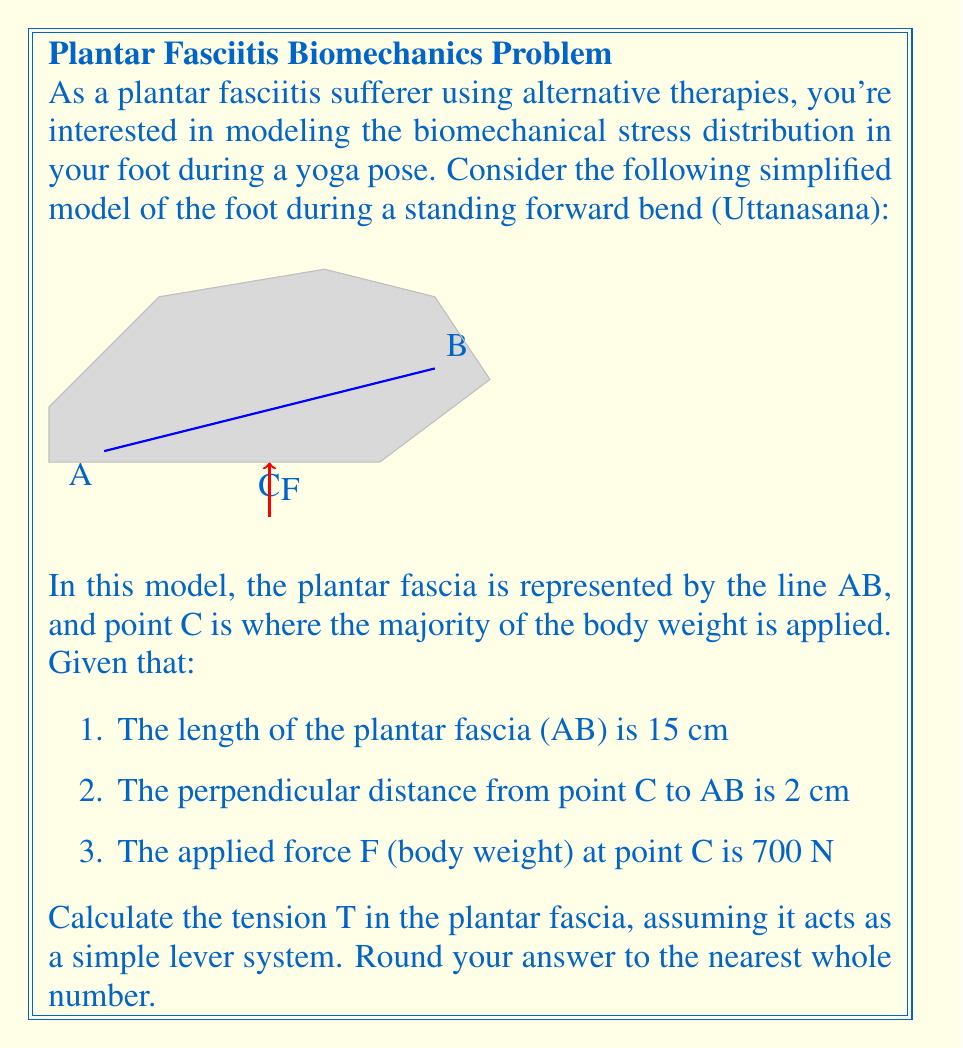Can you solve this math problem? To solve this problem, we'll use the principle of moments and treat the plantar fascia as a lever system. Here's a step-by-step approach:

1) In a lever system, the moment (torque) is calculated as force times perpendicular distance from the pivot point.

2) For equilibrium, the sum of moments about any point should be zero. Let's choose point A as our pivot.

3) The moment due to the body weight (F) about point A is:
   $$M_F = F \times AC$$
   Where AC is the horizontal distance from A to C.

4) The moment due to the tension (T) in the plantar fascia about point A is:
   $$M_T = T \times h$$
   Where h is the perpendicular height of point B above the horizontal.

5) For equilibrium:
   $$M_F = M_T$$
   $$F \times AC = T \times h$$

6) We need to find AC and h:
   - Using the Pythagorean theorem: $AC^2 + 2^2 = 15^2$
   - $AC = \sqrt{15^2 - 2^2} = \sqrt{221} \approx 14.87$ cm
   - $h = 2$ cm (given perpendicular distance)

7) Substituting into the equilibrium equation:
   $$700 \times 14.87 = T \times 2$$

8) Solving for T:
   $$T = \frac{700 \times 14.87}{2} \approx 5204.5 \text{ N}$$

9) Rounding to the nearest whole number:
   $$T \approx 5205 \text{ N}$$
Answer: 5205 N 